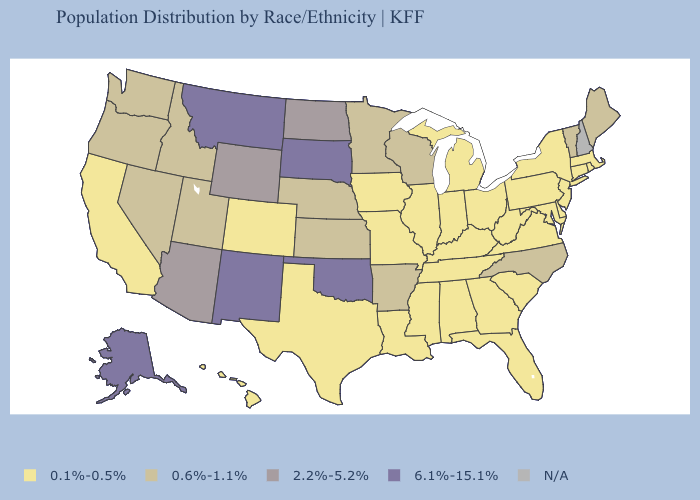What is the value of California?
Quick response, please. 0.1%-0.5%. Which states have the lowest value in the MidWest?
Concise answer only. Illinois, Indiana, Iowa, Michigan, Missouri, Ohio. Does the first symbol in the legend represent the smallest category?
Give a very brief answer. Yes. Which states have the lowest value in the MidWest?
Answer briefly. Illinois, Indiana, Iowa, Michigan, Missouri, Ohio. Among the states that border Nebraska , does Iowa have the lowest value?
Give a very brief answer. Yes. How many symbols are there in the legend?
Give a very brief answer. 5. Name the states that have a value in the range 0.1%-0.5%?
Give a very brief answer. Alabama, California, Colorado, Connecticut, Delaware, Florida, Georgia, Hawaii, Illinois, Indiana, Iowa, Kentucky, Louisiana, Maryland, Massachusetts, Michigan, Mississippi, Missouri, New Jersey, New York, Ohio, Pennsylvania, Rhode Island, South Carolina, Tennessee, Texas, Virginia, West Virginia. Among the states that border Virginia , does West Virginia have the highest value?
Keep it brief. No. Which states have the highest value in the USA?
Short answer required. Alaska, Montana, New Mexico, Oklahoma, South Dakota. Which states have the lowest value in the USA?
Quick response, please. Alabama, California, Colorado, Connecticut, Delaware, Florida, Georgia, Hawaii, Illinois, Indiana, Iowa, Kentucky, Louisiana, Maryland, Massachusetts, Michigan, Mississippi, Missouri, New Jersey, New York, Ohio, Pennsylvania, Rhode Island, South Carolina, Tennessee, Texas, Virginia, West Virginia. How many symbols are there in the legend?
Write a very short answer. 5. Does Wyoming have the lowest value in the West?
Write a very short answer. No. What is the lowest value in the USA?
Keep it brief. 0.1%-0.5%. 